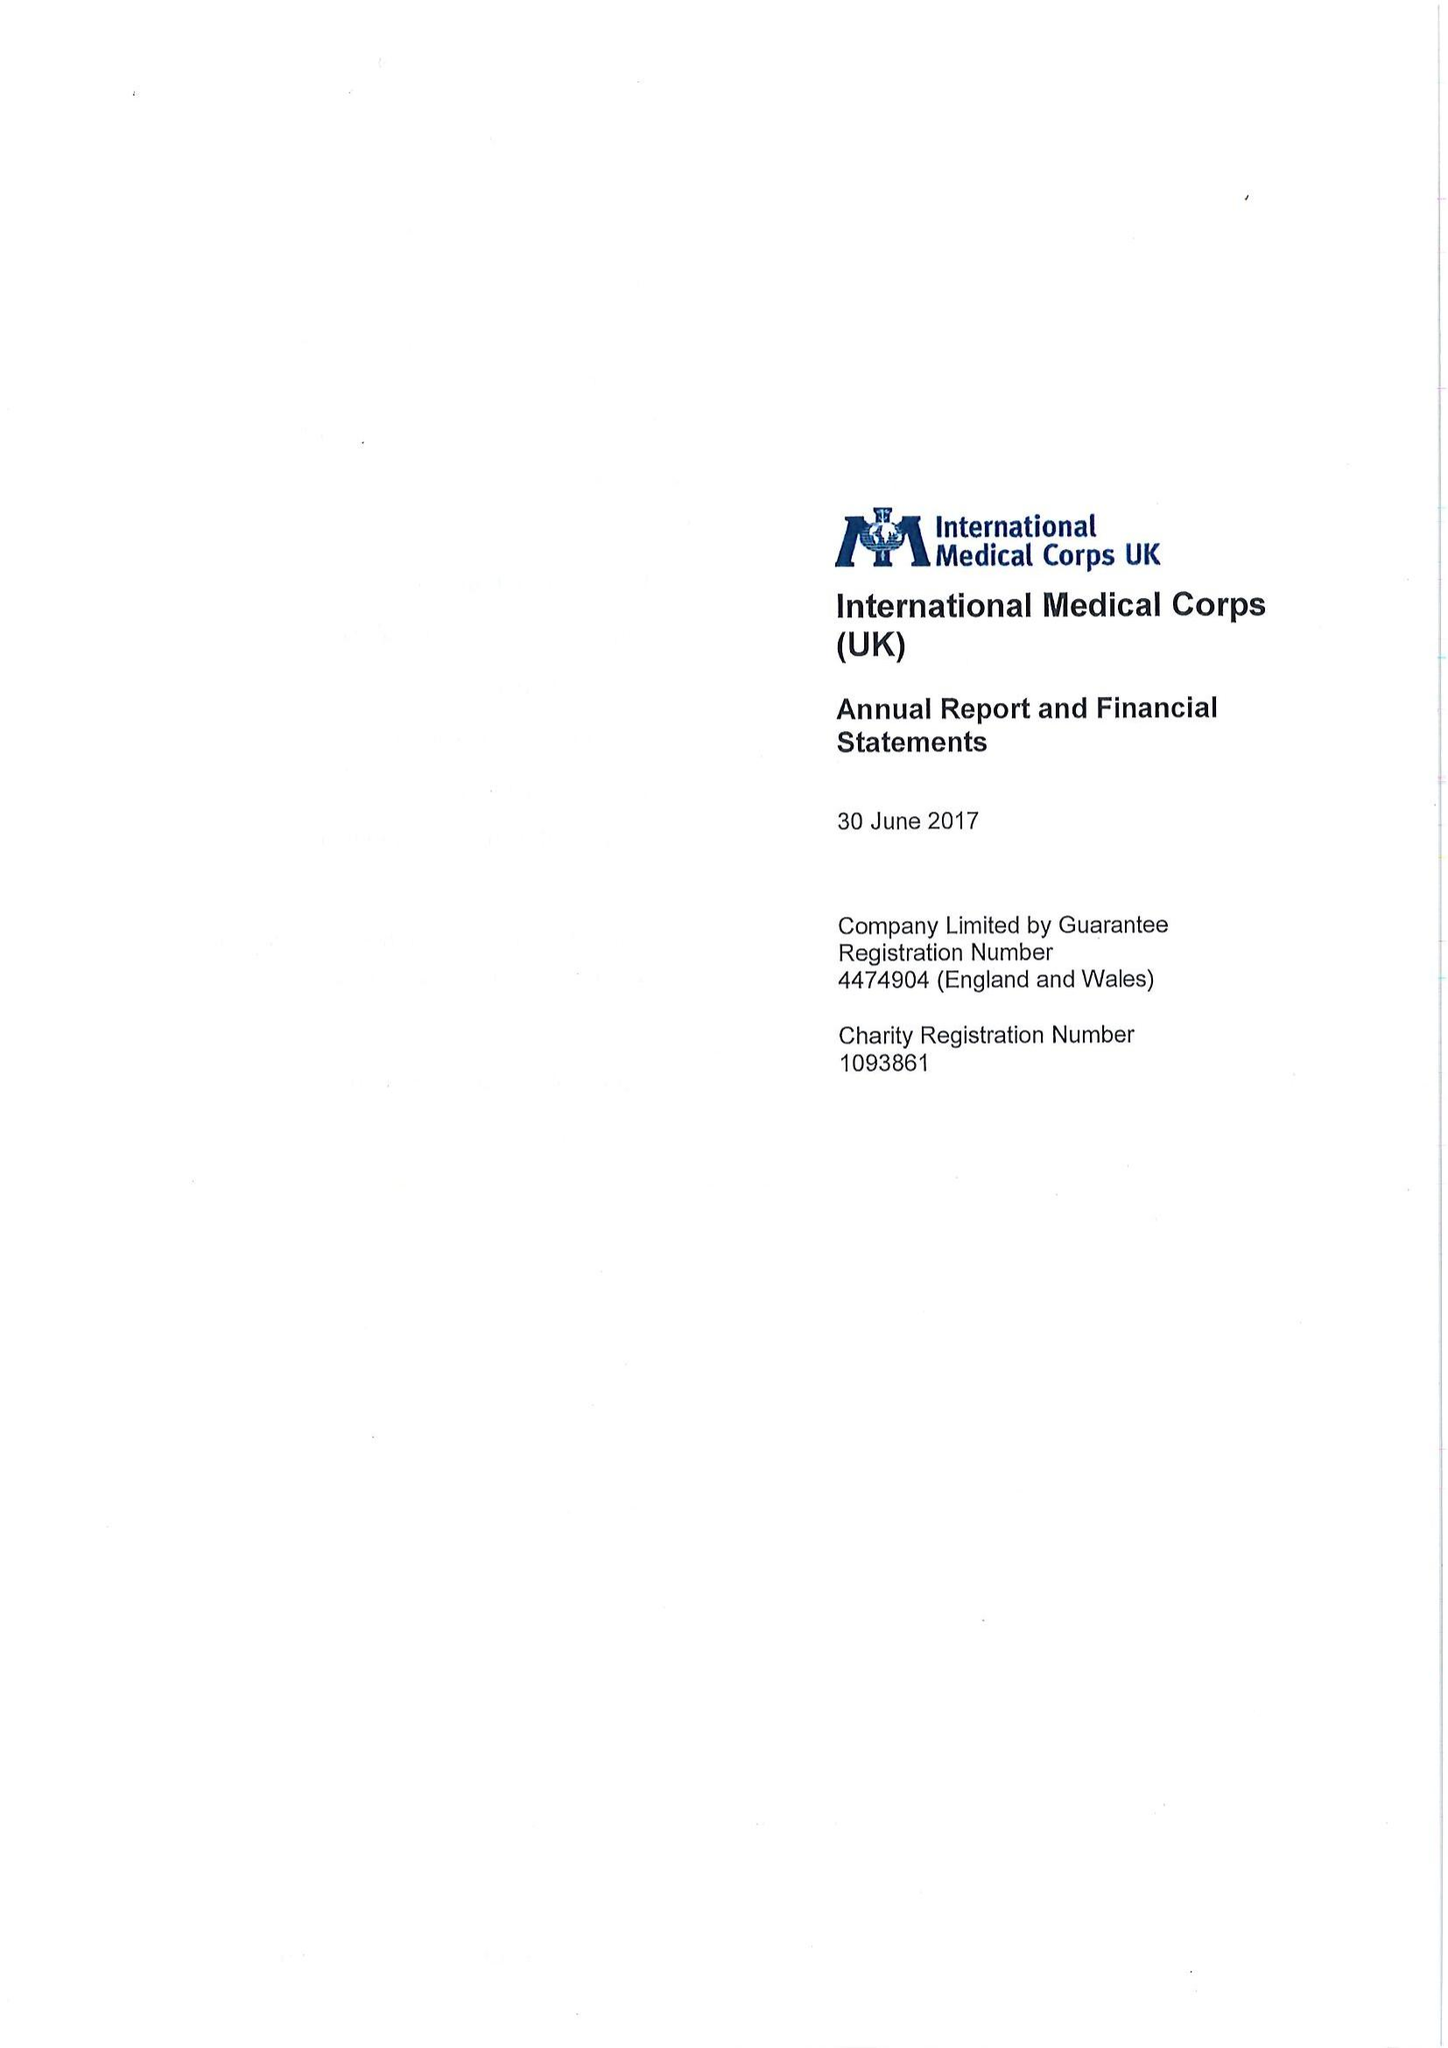What is the value for the address__post_town?
Answer the question using a single word or phrase. LONDON 